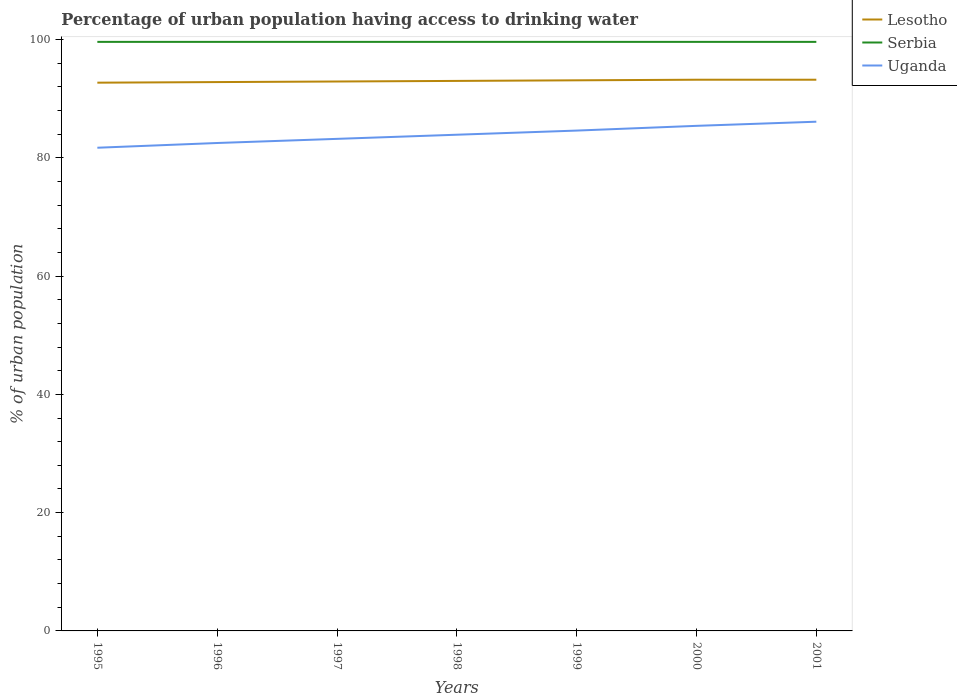How many different coloured lines are there?
Make the answer very short. 3. Is the number of lines equal to the number of legend labels?
Keep it short and to the point. Yes. Across all years, what is the maximum percentage of urban population having access to drinking water in Serbia?
Your response must be concise. 99.6. What is the total percentage of urban population having access to drinking water in Lesotho in the graph?
Offer a terse response. -0.3. What is the difference between the highest and the second highest percentage of urban population having access to drinking water in Uganda?
Provide a succinct answer. 4.4. What is the difference between the highest and the lowest percentage of urban population having access to drinking water in Serbia?
Your answer should be compact. 0. How many lines are there?
Give a very brief answer. 3. Are the values on the major ticks of Y-axis written in scientific E-notation?
Offer a very short reply. No. How are the legend labels stacked?
Give a very brief answer. Vertical. What is the title of the graph?
Your answer should be compact. Percentage of urban population having access to drinking water. What is the label or title of the Y-axis?
Make the answer very short. % of urban population. What is the % of urban population of Lesotho in 1995?
Your answer should be very brief. 92.7. What is the % of urban population in Serbia in 1995?
Offer a terse response. 99.6. What is the % of urban population in Uganda in 1995?
Your answer should be very brief. 81.7. What is the % of urban population of Lesotho in 1996?
Ensure brevity in your answer.  92.8. What is the % of urban population of Serbia in 1996?
Your answer should be very brief. 99.6. What is the % of urban population in Uganda in 1996?
Your response must be concise. 82.5. What is the % of urban population of Lesotho in 1997?
Keep it short and to the point. 92.9. What is the % of urban population of Serbia in 1997?
Your answer should be very brief. 99.6. What is the % of urban population in Uganda in 1997?
Ensure brevity in your answer.  83.2. What is the % of urban population in Lesotho in 1998?
Your response must be concise. 93. What is the % of urban population in Serbia in 1998?
Your answer should be compact. 99.6. What is the % of urban population of Uganda in 1998?
Offer a terse response. 83.9. What is the % of urban population of Lesotho in 1999?
Keep it short and to the point. 93.1. What is the % of urban population in Serbia in 1999?
Make the answer very short. 99.6. What is the % of urban population of Uganda in 1999?
Give a very brief answer. 84.6. What is the % of urban population in Lesotho in 2000?
Offer a very short reply. 93.2. What is the % of urban population in Serbia in 2000?
Ensure brevity in your answer.  99.6. What is the % of urban population in Uganda in 2000?
Your answer should be compact. 85.4. What is the % of urban population in Lesotho in 2001?
Make the answer very short. 93.2. What is the % of urban population in Serbia in 2001?
Keep it short and to the point. 99.6. What is the % of urban population of Uganda in 2001?
Offer a terse response. 86.1. Across all years, what is the maximum % of urban population of Lesotho?
Make the answer very short. 93.2. Across all years, what is the maximum % of urban population of Serbia?
Offer a terse response. 99.6. Across all years, what is the maximum % of urban population of Uganda?
Your response must be concise. 86.1. Across all years, what is the minimum % of urban population of Lesotho?
Provide a short and direct response. 92.7. Across all years, what is the minimum % of urban population in Serbia?
Ensure brevity in your answer.  99.6. Across all years, what is the minimum % of urban population of Uganda?
Make the answer very short. 81.7. What is the total % of urban population in Lesotho in the graph?
Offer a terse response. 650.9. What is the total % of urban population in Serbia in the graph?
Keep it short and to the point. 697.2. What is the total % of urban population in Uganda in the graph?
Your response must be concise. 587.4. What is the difference between the % of urban population of Lesotho in 1995 and that in 1996?
Offer a very short reply. -0.1. What is the difference between the % of urban population of Serbia in 1995 and that in 1997?
Keep it short and to the point. 0. What is the difference between the % of urban population of Uganda in 1995 and that in 1997?
Offer a very short reply. -1.5. What is the difference between the % of urban population of Serbia in 1995 and that in 1999?
Your answer should be compact. 0. What is the difference between the % of urban population of Lesotho in 1995 and that in 2000?
Keep it short and to the point. -0.5. What is the difference between the % of urban population in Uganda in 1995 and that in 2000?
Provide a succinct answer. -3.7. What is the difference between the % of urban population of Lesotho in 1995 and that in 2001?
Keep it short and to the point. -0.5. What is the difference between the % of urban population of Lesotho in 1996 and that in 1997?
Give a very brief answer. -0.1. What is the difference between the % of urban population in Serbia in 1996 and that in 1997?
Ensure brevity in your answer.  0. What is the difference between the % of urban population in Lesotho in 1996 and that in 1998?
Your answer should be compact. -0.2. What is the difference between the % of urban population of Serbia in 1996 and that in 1999?
Your response must be concise. 0. What is the difference between the % of urban population of Lesotho in 1996 and that in 2000?
Offer a very short reply. -0.4. What is the difference between the % of urban population of Serbia in 1996 and that in 2000?
Provide a succinct answer. 0. What is the difference between the % of urban population of Uganda in 1996 and that in 2000?
Your answer should be very brief. -2.9. What is the difference between the % of urban population of Serbia in 1996 and that in 2001?
Offer a terse response. 0. What is the difference between the % of urban population in Uganda in 1996 and that in 2001?
Make the answer very short. -3.6. What is the difference between the % of urban population in Lesotho in 1997 and that in 1998?
Ensure brevity in your answer.  -0.1. What is the difference between the % of urban population of Serbia in 1997 and that in 1998?
Your response must be concise. 0. What is the difference between the % of urban population in Uganda in 1997 and that in 1999?
Ensure brevity in your answer.  -1.4. What is the difference between the % of urban population of Lesotho in 1997 and that in 2001?
Your response must be concise. -0.3. What is the difference between the % of urban population in Uganda in 1997 and that in 2001?
Ensure brevity in your answer.  -2.9. What is the difference between the % of urban population of Serbia in 1998 and that in 1999?
Provide a succinct answer. 0. What is the difference between the % of urban population of Lesotho in 1998 and that in 2000?
Offer a terse response. -0.2. What is the difference between the % of urban population of Lesotho in 1998 and that in 2001?
Ensure brevity in your answer.  -0.2. What is the difference between the % of urban population of Serbia in 1998 and that in 2001?
Your answer should be very brief. 0. What is the difference between the % of urban population of Lesotho in 1999 and that in 2000?
Keep it short and to the point. -0.1. What is the difference between the % of urban population in Uganda in 1999 and that in 2000?
Give a very brief answer. -0.8. What is the difference between the % of urban population of Serbia in 1999 and that in 2001?
Make the answer very short. 0. What is the difference between the % of urban population of Lesotho in 2000 and that in 2001?
Make the answer very short. 0. What is the difference between the % of urban population in Serbia in 2000 and that in 2001?
Keep it short and to the point. 0. What is the difference between the % of urban population in Uganda in 2000 and that in 2001?
Your answer should be very brief. -0.7. What is the difference between the % of urban population in Lesotho in 1995 and the % of urban population in Uganda in 1996?
Ensure brevity in your answer.  10.2. What is the difference between the % of urban population of Lesotho in 1995 and the % of urban population of Uganda in 1997?
Offer a very short reply. 9.5. What is the difference between the % of urban population of Serbia in 1995 and the % of urban population of Uganda in 1997?
Keep it short and to the point. 16.4. What is the difference between the % of urban population in Lesotho in 1995 and the % of urban population in Uganda in 1998?
Make the answer very short. 8.8. What is the difference between the % of urban population of Serbia in 1995 and the % of urban population of Uganda in 1999?
Offer a terse response. 15. What is the difference between the % of urban population of Lesotho in 1995 and the % of urban population of Uganda in 2000?
Your answer should be very brief. 7.3. What is the difference between the % of urban population in Serbia in 1995 and the % of urban population in Uganda in 2000?
Your answer should be very brief. 14.2. What is the difference between the % of urban population in Lesotho in 1995 and the % of urban population in Uganda in 2001?
Your answer should be compact. 6.6. What is the difference between the % of urban population in Lesotho in 1996 and the % of urban population in Uganda in 1997?
Offer a very short reply. 9.6. What is the difference between the % of urban population in Serbia in 1996 and the % of urban population in Uganda in 1997?
Give a very brief answer. 16.4. What is the difference between the % of urban population in Lesotho in 1996 and the % of urban population in Serbia in 1998?
Offer a terse response. -6.8. What is the difference between the % of urban population of Lesotho in 1996 and the % of urban population of Serbia in 1999?
Provide a succinct answer. -6.8. What is the difference between the % of urban population in Lesotho in 1996 and the % of urban population in Uganda in 1999?
Offer a very short reply. 8.2. What is the difference between the % of urban population of Lesotho in 1996 and the % of urban population of Uganda in 2000?
Offer a very short reply. 7.4. What is the difference between the % of urban population in Lesotho in 1996 and the % of urban population in Serbia in 2001?
Your response must be concise. -6.8. What is the difference between the % of urban population of Lesotho in 1997 and the % of urban population of Uganda in 1998?
Your answer should be very brief. 9. What is the difference between the % of urban population in Serbia in 1997 and the % of urban population in Uganda in 1999?
Give a very brief answer. 15. What is the difference between the % of urban population in Lesotho in 1997 and the % of urban population in Serbia in 2000?
Provide a succinct answer. -6.7. What is the difference between the % of urban population in Lesotho in 1997 and the % of urban population in Uganda in 2000?
Make the answer very short. 7.5. What is the difference between the % of urban population in Serbia in 1997 and the % of urban population in Uganda in 2001?
Your answer should be very brief. 13.5. What is the difference between the % of urban population in Lesotho in 1998 and the % of urban population in Serbia in 1999?
Keep it short and to the point. -6.6. What is the difference between the % of urban population in Serbia in 1998 and the % of urban population in Uganda in 1999?
Give a very brief answer. 15. What is the difference between the % of urban population of Serbia in 1998 and the % of urban population of Uganda in 2000?
Offer a very short reply. 14.2. What is the difference between the % of urban population in Lesotho in 1998 and the % of urban population in Serbia in 2001?
Ensure brevity in your answer.  -6.6. What is the difference between the % of urban population in Lesotho in 1998 and the % of urban population in Uganda in 2001?
Ensure brevity in your answer.  6.9. What is the difference between the % of urban population in Lesotho in 1999 and the % of urban population in Serbia in 2000?
Give a very brief answer. -6.5. What is the difference between the % of urban population of Lesotho in 1999 and the % of urban population of Uganda in 2000?
Offer a very short reply. 7.7. What is the difference between the % of urban population in Lesotho in 1999 and the % of urban population in Serbia in 2001?
Provide a succinct answer. -6.5. What is the difference between the % of urban population in Lesotho in 1999 and the % of urban population in Uganda in 2001?
Offer a terse response. 7. What is the difference between the % of urban population in Serbia in 1999 and the % of urban population in Uganda in 2001?
Provide a short and direct response. 13.5. What is the difference between the % of urban population of Lesotho in 2000 and the % of urban population of Serbia in 2001?
Provide a succinct answer. -6.4. What is the average % of urban population of Lesotho per year?
Keep it short and to the point. 92.99. What is the average % of urban population in Serbia per year?
Ensure brevity in your answer.  99.6. What is the average % of urban population in Uganda per year?
Your answer should be compact. 83.91. In the year 1996, what is the difference between the % of urban population of Lesotho and % of urban population of Serbia?
Offer a terse response. -6.8. In the year 1996, what is the difference between the % of urban population of Serbia and % of urban population of Uganda?
Offer a very short reply. 17.1. In the year 1997, what is the difference between the % of urban population in Lesotho and % of urban population in Serbia?
Keep it short and to the point. -6.7. In the year 1997, what is the difference between the % of urban population of Lesotho and % of urban population of Uganda?
Offer a very short reply. 9.7. In the year 1997, what is the difference between the % of urban population of Serbia and % of urban population of Uganda?
Your answer should be compact. 16.4. In the year 1998, what is the difference between the % of urban population of Lesotho and % of urban population of Uganda?
Offer a very short reply. 9.1. In the year 1998, what is the difference between the % of urban population in Serbia and % of urban population in Uganda?
Ensure brevity in your answer.  15.7. In the year 1999, what is the difference between the % of urban population of Serbia and % of urban population of Uganda?
Make the answer very short. 15. In the year 2000, what is the difference between the % of urban population in Lesotho and % of urban population in Serbia?
Keep it short and to the point. -6.4. In the year 2000, what is the difference between the % of urban population of Lesotho and % of urban population of Uganda?
Provide a succinct answer. 7.8. In the year 2000, what is the difference between the % of urban population in Serbia and % of urban population in Uganda?
Your answer should be compact. 14.2. In the year 2001, what is the difference between the % of urban population of Lesotho and % of urban population of Serbia?
Offer a very short reply. -6.4. In the year 2001, what is the difference between the % of urban population of Lesotho and % of urban population of Uganda?
Give a very brief answer. 7.1. What is the ratio of the % of urban population in Lesotho in 1995 to that in 1996?
Your response must be concise. 1. What is the ratio of the % of urban population in Uganda in 1995 to that in 1996?
Your answer should be compact. 0.99. What is the ratio of the % of urban population in Lesotho in 1995 to that in 1997?
Give a very brief answer. 1. What is the ratio of the % of urban population in Serbia in 1995 to that in 1997?
Offer a very short reply. 1. What is the ratio of the % of urban population of Uganda in 1995 to that in 1998?
Your answer should be compact. 0.97. What is the ratio of the % of urban population in Uganda in 1995 to that in 1999?
Offer a very short reply. 0.97. What is the ratio of the % of urban population of Serbia in 1995 to that in 2000?
Offer a terse response. 1. What is the ratio of the % of urban population in Uganda in 1995 to that in 2000?
Offer a very short reply. 0.96. What is the ratio of the % of urban population in Serbia in 1995 to that in 2001?
Offer a very short reply. 1. What is the ratio of the % of urban population in Uganda in 1995 to that in 2001?
Provide a short and direct response. 0.95. What is the ratio of the % of urban population in Lesotho in 1996 to that in 1997?
Your response must be concise. 1. What is the ratio of the % of urban population in Uganda in 1996 to that in 1997?
Your answer should be very brief. 0.99. What is the ratio of the % of urban population in Lesotho in 1996 to that in 1998?
Give a very brief answer. 1. What is the ratio of the % of urban population of Uganda in 1996 to that in 1998?
Your answer should be very brief. 0.98. What is the ratio of the % of urban population in Lesotho in 1996 to that in 1999?
Make the answer very short. 1. What is the ratio of the % of urban population in Uganda in 1996 to that in 1999?
Offer a very short reply. 0.98. What is the ratio of the % of urban population in Lesotho in 1996 to that in 2000?
Ensure brevity in your answer.  1. What is the ratio of the % of urban population of Lesotho in 1996 to that in 2001?
Make the answer very short. 1. What is the ratio of the % of urban population in Uganda in 1996 to that in 2001?
Keep it short and to the point. 0.96. What is the ratio of the % of urban population of Lesotho in 1997 to that in 1998?
Provide a succinct answer. 1. What is the ratio of the % of urban population of Uganda in 1997 to that in 1998?
Offer a very short reply. 0.99. What is the ratio of the % of urban population in Lesotho in 1997 to that in 1999?
Give a very brief answer. 1. What is the ratio of the % of urban population in Serbia in 1997 to that in 1999?
Provide a short and direct response. 1. What is the ratio of the % of urban population of Uganda in 1997 to that in 1999?
Your response must be concise. 0.98. What is the ratio of the % of urban population in Lesotho in 1997 to that in 2000?
Keep it short and to the point. 1. What is the ratio of the % of urban population in Serbia in 1997 to that in 2000?
Keep it short and to the point. 1. What is the ratio of the % of urban population in Uganda in 1997 to that in 2000?
Offer a terse response. 0.97. What is the ratio of the % of urban population of Lesotho in 1997 to that in 2001?
Keep it short and to the point. 1. What is the ratio of the % of urban population in Serbia in 1997 to that in 2001?
Ensure brevity in your answer.  1. What is the ratio of the % of urban population in Uganda in 1997 to that in 2001?
Ensure brevity in your answer.  0.97. What is the ratio of the % of urban population in Lesotho in 1998 to that in 1999?
Your answer should be compact. 1. What is the ratio of the % of urban population of Lesotho in 1998 to that in 2000?
Keep it short and to the point. 1. What is the ratio of the % of urban population of Serbia in 1998 to that in 2000?
Offer a very short reply. 1. What is the ratio of the % of urban population of Uganda in 1998 to that in 2000?
Your response must be concise. 0.98. What is the ratio of the % of urban population of Lesotho in 1998 to that in 2001?
Your answer should be very brief. 1. What is the ratio of the % of urban population in Uganda in 1998 to that in 2001?
Keep it short and to the point. 0.97. What is the ratio of the % of urban population in Serbia in 1999 to that in 2000?
Provide a succinct answer. 1. What is the ratio of the % of urban population of Uganda in 1999 to that in 2000?
Give a very brief answer. 0.99. What is the ratio of the % of urban population of Lesotho in 1999 to that in 2001?
Your answer should be very brief. 1. What is the ratio of the % of urban population of Uganda in 1999 to that in 2001?
Provide a short and direct response. 0.98. What is the ratio of the % of urban population of Lesotho in 2000 to that in 2001?
Your answer should be compact. 1. What is the ratio of the % of urban population of Serbia in 2000 to that in 2001?
Offer a terse response. 1. What is the difference between the highest and the second highest % of urban population in Lesotho?
Provide a succinct answer. 0. What is the difference between the highest and the lowest % of urban population of Lesotho?
Provide a short and direct response. 0.5. What is the difference between the highest and the lowest % of urban population in Serbia?
Offer a terse response. 0. 